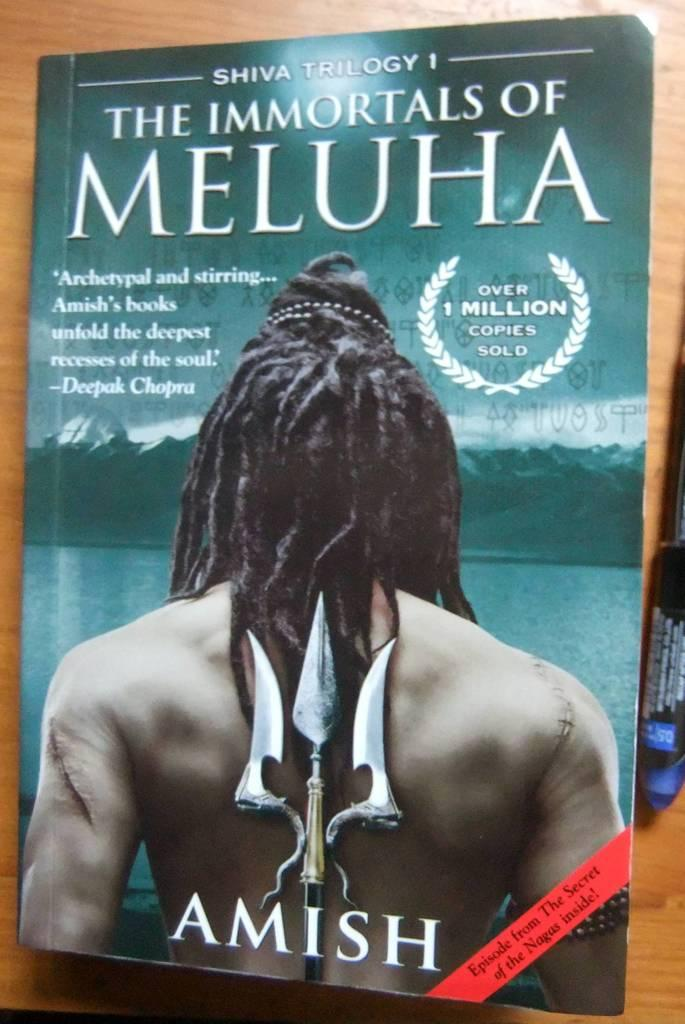Provide a one-sentence caption for the provided image. a novel writen by Amish titled the immortals of meluha. 